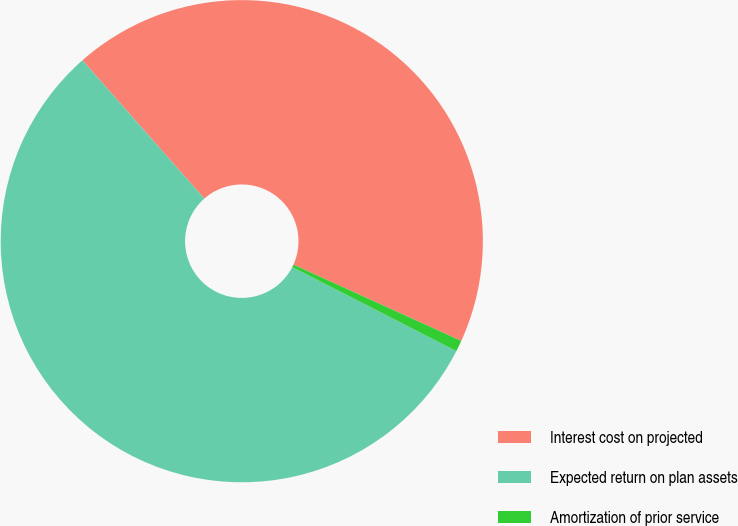Convert chart to OTSL. <chart><loc_0><loc_0><loc_500><loc_500><pie_chart><fcel>Interest cost on projected<fcel>Expected return on plan assets<fcel>Amortization of prior service<nl><fcel>43.28%<fcel>55.97%<fcel>0.75%<nl></chart> 